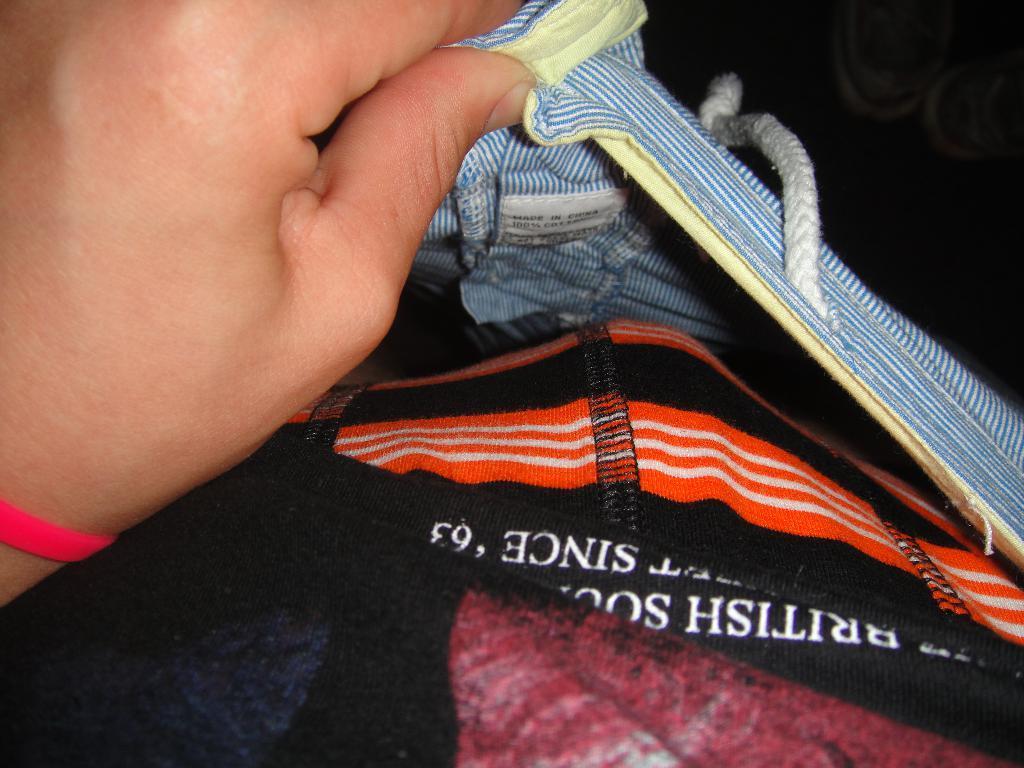Please provide a concise description of this image. In this image there is a person holding clothes and there is some text written on the cloth. 